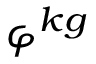<formula> <loc_0><loc_0><loc_500><loc_500>\varphi ^ { k g }</formula> 